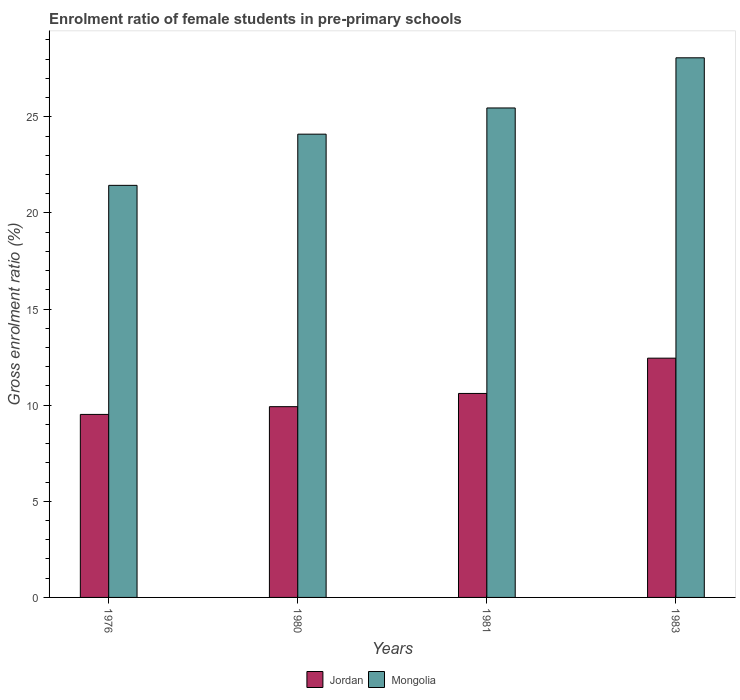How many groups of bars are there?
Make the answer very short. 4. How many bars are there on the 4th tick from the left?
Provide a succinct answer. 2. How many bars are there on the 1st tick from the right?
Your answer should be compact. 2. What is the label of the 3rd group of bars from the left?
Your response must be concise. 1981. What is the enrolment ratio of female students in pre-primary schools in Mongolia in 1980?
Your answer should be very brief. 24.1. Across all years, what is the maximum enrolment ratio of female students in pre-primary schools in Jordan?
Your response must be concise. 12.45. Across all years, what is the minimum enrolment ratio of female students in pre-primary schools in Jordan?
Offer a very short reply. 9.52. In which year was the enrolment ratio of female students in pre-primary schools in Mongolia minimum?
Offer a terse response. 1976. What is the total enrolment ratio of female students in pre-primary schools in Mongolia in the graph?
Provide a short and direct response. 99.07. What is the difference between the enrolment ratio of female students in pre-primary schools in Mongolia in 1980 and that in 1983?
Give a very brief answer. -3.97. What is the difference between the enrolment ratio of female students in pre-primary schools in Jordan in 1981 and the enrolment ratio of female students in pre-primary schools in Mongolia in 1976?
Offer a very short reply. -10.83. What is the average enrolment ratio of female students in pre-primary schools in Mongolia per year?
Offer a very short reply. 24.77. In the year 1983, what is the difference between the enrolment ratio of female students in pre-primary schools in Jordan and enrolment ratio of female students in pre-primary schools in Mongolia?
Keep it short and to the point. -15.63. In how many years, is the enrolment ratio of female students in pre-primary schools in Jordan greater than 8 %?
Make the answer very short. 4. What is the ratio of the enrolment ratio of female students in pre-primary schools in Mongolia in 1980 to that in 1981?
Ensure brevity in your answer.  0.95. Is the enrolment ratio of female students in pre-primary schools in Mongolia in 1981 less than that in 1983?
Provide a short and direct response. Yes. Is the difference between the enrolment ratio of female students in pre-primary schools in Jordan in 1980 and 1981 greater than the difference between the enrolment ratio of female students in pre-primary schools in Mongolia in 1980 and 1981?
Give a very brief answer. Yes. What is the difference between the highest and the second highest enrolment ratio of female students in pre-primary schools in Mongolia?
Offer a terse response. 2.61. What is the difference between the highest and the lowest enrolment ratio of female students in pre-primary schools in Mongolia?
Make the answer very short. 6.63. In how many years, is the enrolment ratio of female students in pre-primary schools in Mongolia greater than the average enrolment ratio of female students in pre-primary schools in Mongolia taken over all years?
Ensure brevity in your answer.  2. What does the 1st bar from the left in 1981 represents?
Keep it short and to the point. Jordan. What does the 1st bar from the right in 1983 represents?
Your answer should be compact. Mongolia. How many bars are there?
Keep it short and to the point. 8. Are all the bars in the graph horizontal?
Ensure brevity in your answer.  No. How many years are there in the graph?
Provide a short and direct response. 4. Does the graph contain any zero values?
Your response must be concise. No. Does the graph contain grids?
Keep it short and to the point. No. Where does the legend appear in the graph?
Your answer should be compact. Bottom center. How many legend labels are there?
Your response must be concise. 2. What is the title of the graph?
Your answer should be compact. Enrolment ratio of female students in pre-primary schools. What is the label or title of the X-axis?
Offer a very short reply. Years. What is the label or title of the Y-axis?
Keep it short and to the point. Gross enrolment ratio (%). What is the Gross enrolment ratio (%) of Jordan in 1976?
Offer a terse response. 9.52. What is the Gross enrolment ratio (%) of Mongolia in 1976?
Offer a terse response. 21.44. What is the Gross enrolment ratio (%) in Jordan in 1980?
Make the answer very short. 9.92. What is the Gross enrolment ratio (%) of Mongolia in 1980?
Ensure brevity in your answer.  24.1. What is the Gross enrolment ratio (%) of Jordan in 1981?
Provide a succinct answer. 10.61. What is the Gross enrolment ratio (%) in Mongolia in 1981?
Offer a terse response. 25.46. What is the Gross enrolment ratio (%) in Jordan in 1983?
Your answer should be compact. 12.45. What is the Gross enrolment ratio (%) of Mongolia in 1983?
Your answer should be compact. 28.07. Across all years, what is the maximum Gross enrolment ratio (%) in Jordan?
Your answer should be compact. 12.45. Across all years, what is the maximum Gross enrolment ratio (%) in Mongolia?
Provide a short and direct response. 28.07. Across all years, what is the minimum Gross enrolment ratio (%) in Jordan?
Provide a short and direct response. 9.52. Across all years, what is the minimum Gross enrolment ratio (%) of Mongolia?
Offer a terse response. 21.44. What is the total Gross enrolment ratio (%) of Jordan in the graph?
Offer a very short reply. 42.5. What is the total Gross enrolment ratio (%) of Mongolia in the graph?
Offer a terse response. 99.07. What is the difference between the Gross enrolment ratio (%) in Jordan in 1976 and that in 1980?
Give a very brief answer. -0.4. What is the difference between the Gross enrolment ratio (%) of Mongolia in 1976 and that in 1980?
Give a very brief answer. -2.66. What is the difference between the Gross enrolment ratio (%) of Jordan in 1976 and that in 1981?
Your answer should be compact. -1.09. What is the difference between the Gross enrolment ratio (%) in Mongolia in 1976 and that in 1981?
Give a very brief answer. -4.03. What is the difference between the Gross enrolment ratio (%) in Jordan in 1976 and that in 1983?
Your response must be concise. -2.93. What is the difference between the Gross enrolment ratio (%) in Mongolia in 1976 and that in 1983?
Provide a succinct answer. -6.63. What is the difference between the Gross enrolment ratio (%) of Jordan in 1980 and that in 1981?
Provide a short and direct response. -0.69. What is the difference between the Gross enrolment ratio (%) of Mongolia in 1980 and that in 1981?
Your response must be concise. -1.36. What is the difference between the Gross enrolment ratio (%) of Jordan in 1980 and that in 1983?
Keep it short and to the point. -2.52. What is the difference between the Gross enrolment ratio (%) in Mongolia in 1980 and that in 1983?
Your answer should be compact. -3.97. What is the difference between the Gross enrolment ratio (%) in Jordan in 1981 and that in 1983?
Make the answer very short. -1.83. What is the difference between the Gross enrolment ratio (%) in Mongolia in 1981 and that in 1983?
Keep it short and to the point. -2.61. What is the difference between the Gross enrolment ratio (%) of Jordan in 1976 and the Gross enrolment ratio (%) of Mongolia in 1980?
Offer a terse response. -14.58. What is the difference between the Gross enrolment ratio (%) in Jordan in 1976 and the Gross enrolment ratio (%) in Mongolia in 1981?
Your answer should be very brief. -15.94. What is the difference between the Gross enrolment ratio (%) in Jordan in 1976 and the Gross enrolment ratio (%) in Mongolia in 1983?
Provide a short and direct response. -18.55. What is the difference between the Gross enrolment ratio (%) in Jordan in 1980 and the Gross enrolment ratio (%) in Mongolia in 1981?
Make the answer very short. -15.54. What is the difference between the Gross enrolment ratio (%) in Jordan in 1980 and the Gross enrolment ratio (%) in Mongolia in 1983?
Provide a succinct answer. -18.15. What is the difference between the Gross enrolment ratio (%) in Jordan in 1981 and the Gross enrolment ratio (%) in Mongolia in 1983?
Ensure brevity in your answer.  -17.46. What is the average Gross enrolment ratio (%) in Jordan per year?
Provide a succinct answer. 10.63. What is the average Gross enrolment ratio (%) of Mongolia per year?
Keep it short and to the point. 24.77. In the year 1976, what is the difference between the Gross enrolment ratio (%) of Jordan and Gross enrolment ratio (%) of Mongolia?
Keep it short and to the point. -11.92. In the year 1980, what is the difference between the Gross enrolment ratio (%) of Jordan and Gross enrolment ratio (%) of Mongolia?
Your response must be concise. -14.18. In the year 1981, what is the difference between the Gross enrolment ratio (%) of Jordan and Gross enrolment ratio (%) of Mongolia?
Provide a succinct answer. -14.85. In the year 1983, what is the difference between the Gross enrolment ratio (%) of Jordan and Gross enrolment ratio (%) of Mongolia?
Keep it short and to the point. -15.63. What is the ratio of the Gross enrolment ratio (%) of Jordan in 1976 to that in 1980?
Your answer should be compact. 0.96. What is the ratio of the Gross enrolment ratio (%) of Mongolia in 1976 to that in 1980?
Your answer should be compact. 0.89. What is the ratio of the Gross enrolment ratio (%) in Jordan in 1976 to that in 1981?
Provide a succinct answer. 0.9. What is the ratio of the Gross enrolment ratio (%) in Mongolia in 1976 to that in 1981?
Offer a very short reply. 0.84. What is the ratio of the Gross enrolment ratio (%) in Jordan in 1976 to that in 1983?
Offer a very short reply. 0.76. What is the ratio of the Gross enrolment ratio (%) in Mongolia in 1976 to that in 1983?
Make the answer very short. 0.76. What is the ratio of the Gross enrolment ratio (%) of Jordan in 1980 to that in 1981?
Provide a succinct answer. 0.94. What is the ratio of the Gross enrolment ratio (%) of Mongolia in 1980 to that in 1981?
Ensure brevity in your answer.  0.95. What is the ratio of the Gross enrolment ratio (%) in Jordan in 1980 to that in 1983?
Provide a short and direct response. 0.8. What is the ratio of the Gross enrolment ratio (%) of Mongolia in 1980 to that in 1983?
Provide a succinct answer. 0.86. What is the ratio of the Gross enrolment ratio (%) of Jordan in 1981 to that in 1983?
Provide a short and direct response. 0.85. What is the ratio of the Gross enrolment ratio (%) of Mongolia in 1981 to that in 1983?
Give a very brief answer. 0.91. What is the difference between the highest and the second highest Gross enrolment ratio (%) of Jordan?
Offer a terse response. 1.83. What is the difference between the highest and the second highest Gross enrolment ratio (%) of Mongolia?
Ensure brevity in your answer.  2.61. What is the difference between the highest and the lowest Gross enrolment ratio (%) in Jordan?
Offer a terse response. 2.93. What is the difference between the highest and the lowest Gross enrolment ratio (%) in Mongolia?
Provide a short and direct response. 6.63. 